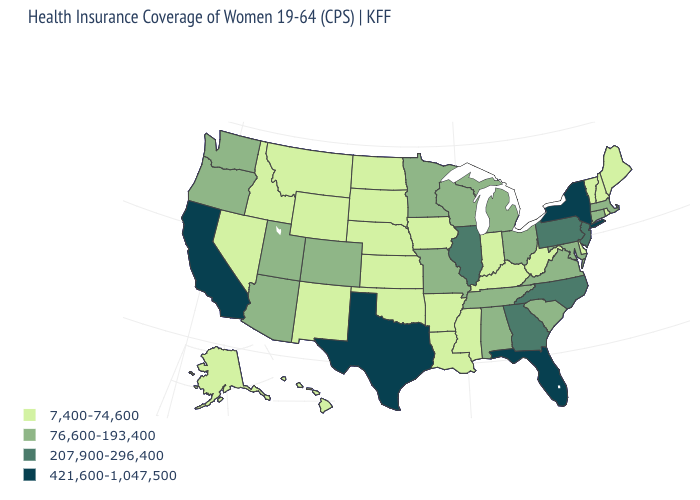What is the highest value in the USA?
Short answer required. 421,600-1,047,500. What is the value of New Mexico?
Quick response, please. 7,400-74,600. Which states have the lowest value in the USA?
Concise answer only. Alaska, Arkansas, Delaware, Hawaii, Idaho, Indiana, Iowa, Kansas, Kentucky, Louisiana, Maine, Mississippi, Montana, Nebraska, Nevada, New Hampshire, New Mexico, North Dakota, Oklahoma, Rhode Island, South Dakota, Vermont, West Virginia, Wyoming. Name the states that have a value in the range 7,400-74,600?
Concise answer only. Alaska, Arkansas, Delaware, Hawaii, Idaho, Indiana, Iowa, Kansas, Kentucky, Louisiana, Maine, Mississippi, Montana, Nebraska, Nevada, New Hampshire, New Mexico, North Dakota, Oklahoma, Rhode Island, South Dakota, Vermont, West Virginia, Wyoming. What is the value of New Jersey?
Be succinct. 207,900-296,400. Is the legend a continuous bar?
Be succinct. No. Does Wisconsin have the lowest value in the USA?
Give a very brief answer. No. What is the value of South Carolina?
Concise answer only. 76,600-193,400. What is the value of Rhode Island?
Keep it brief. 7,400-74,600. What is the highest value in the USA?
Concise answer only. 421,600-1,047,500. Name the states that have a value in the range 76,600-193,400?
Write a very short answer. Alabama, Arizona, Colorado, Connecticut, Maryland, Massachusetts, Michigan, Minnesota, Missouri, Ohio, Oregon, South Carolina, Tennessee, Utah, Virginia, Washington, Wisconsin. Among the states that border Utah , does Nevada have the lowest value?
Short answer required. Yes. What is the value of New Hampshire?
Quick response, please. 7,400-74,600. What is the value of Tennessee?
Keep it brief. 76,600-193,400. Among the states that border Alabama , which have the highest value?
Keep it brief. Florida. 